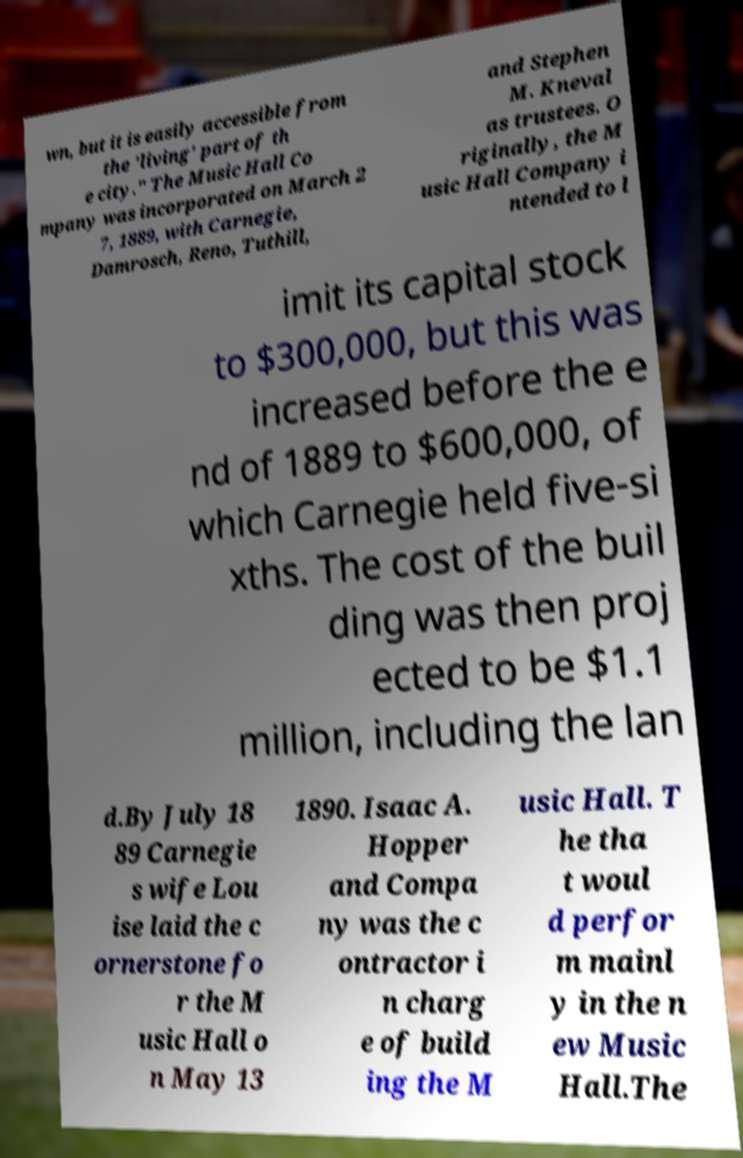Can you read and provide the text displayed in the image?This photo seems to have some interesting text. Can you extract and type it out for me? wn, but it is easily accessible from the 'living' part of th e city." The Music Hall Co mpany was incorporated on March 2 7, 1889, with Carnegie, Damrosch, Reno, Tuthill, and Stephen M. Kneval as trustees. O riginally, the M usic Hall Company i ntended to l imit its capital stock to $300,000, but this was increased before the e nd of 1889 to $600,000, of which Carnegie held five-si xths. The cost of the buil ding was then proj ected to be $1.1 million, including the lan d.By July 18 89 Carnegie s wife Lou ise laid the c ornerstone fo r the M usic Hall o n May 13 1890. Isaac A. Hopper and Compa ny was the c ontractor i n charg e of build ing the M usic Hall. T he tha t woul d perfor m mainl y in the n ew Music Hall.The 